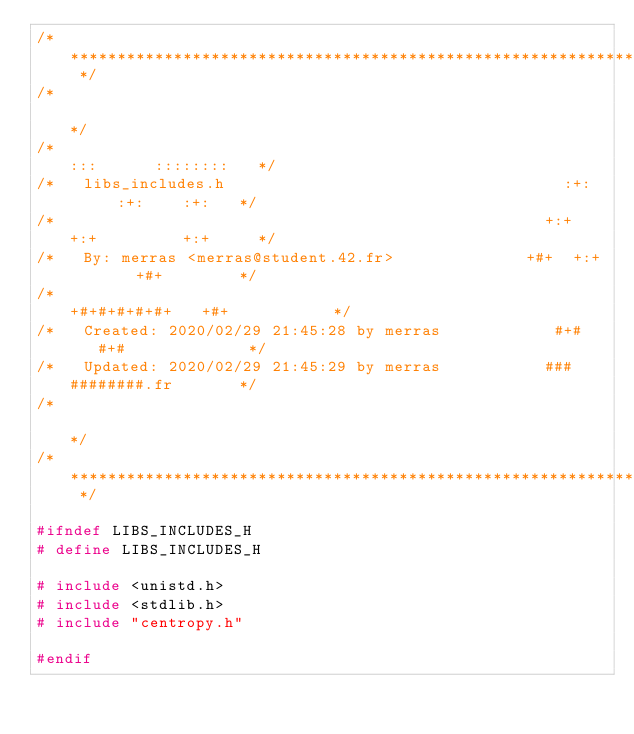<code> <loc_0><loc_0><loc_500><loc_500><_C_>/* ************************************************************************** */
/*                                                                            */
/*                                                        :::      ::::::::   */
/*   libs_includes.h                                    :+:      :+:    :+:   */
/*                                                    +:+ +:+         +:+     */
/*   By: merras <merras@student.42.fr>              +#+  +:+       +#+        */
/*                                                +#+#+#+#+#+   +#+           */
/*   Created: 2020/02/29 21:45:28 by merras            #+#    #+#             */
/*   Updated: 2020/02/29 21:45:29 by merras           ###   ########.fr       */
/*                                                                            */
/* ************************************************************************** */

#ifndef LIBS_INCLUDES_H
# define LIBS_INCLUDES_H

# include <unistd.h>
# include <stdlib.h>
# include "centropy.h"

#endif
</code> 